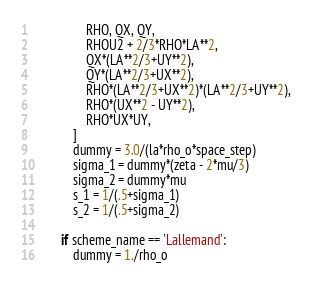<code> <loc_0><loc_0><loc_500><loc_500><_Python_>                RHO, QX, QY,
                RHOU2 + 2/3*RHO*LA**2,
                QX*(LA**2/3+UY**2),
                QY*(LA**2/3+UX**2),
                RHO*(LA**2/3+UX**2)*(LA**2/3+UY**2),
                RHO*(UX**2 - UY**2),
                RHO*UX*UY,
            ]
            dummy = 3.0/(la*rho_o*space_step)
            sigma_1 = dummy*(zeta - 2*mu/3)
            sigma_2 = dummy*mu
            s_1 = 1/(.5+sigma_1)
            s_2 = 1/(.5+sigma_2)

        if scheme_name == 'Lallemand':
            dummy = 1./rho_o</code> 